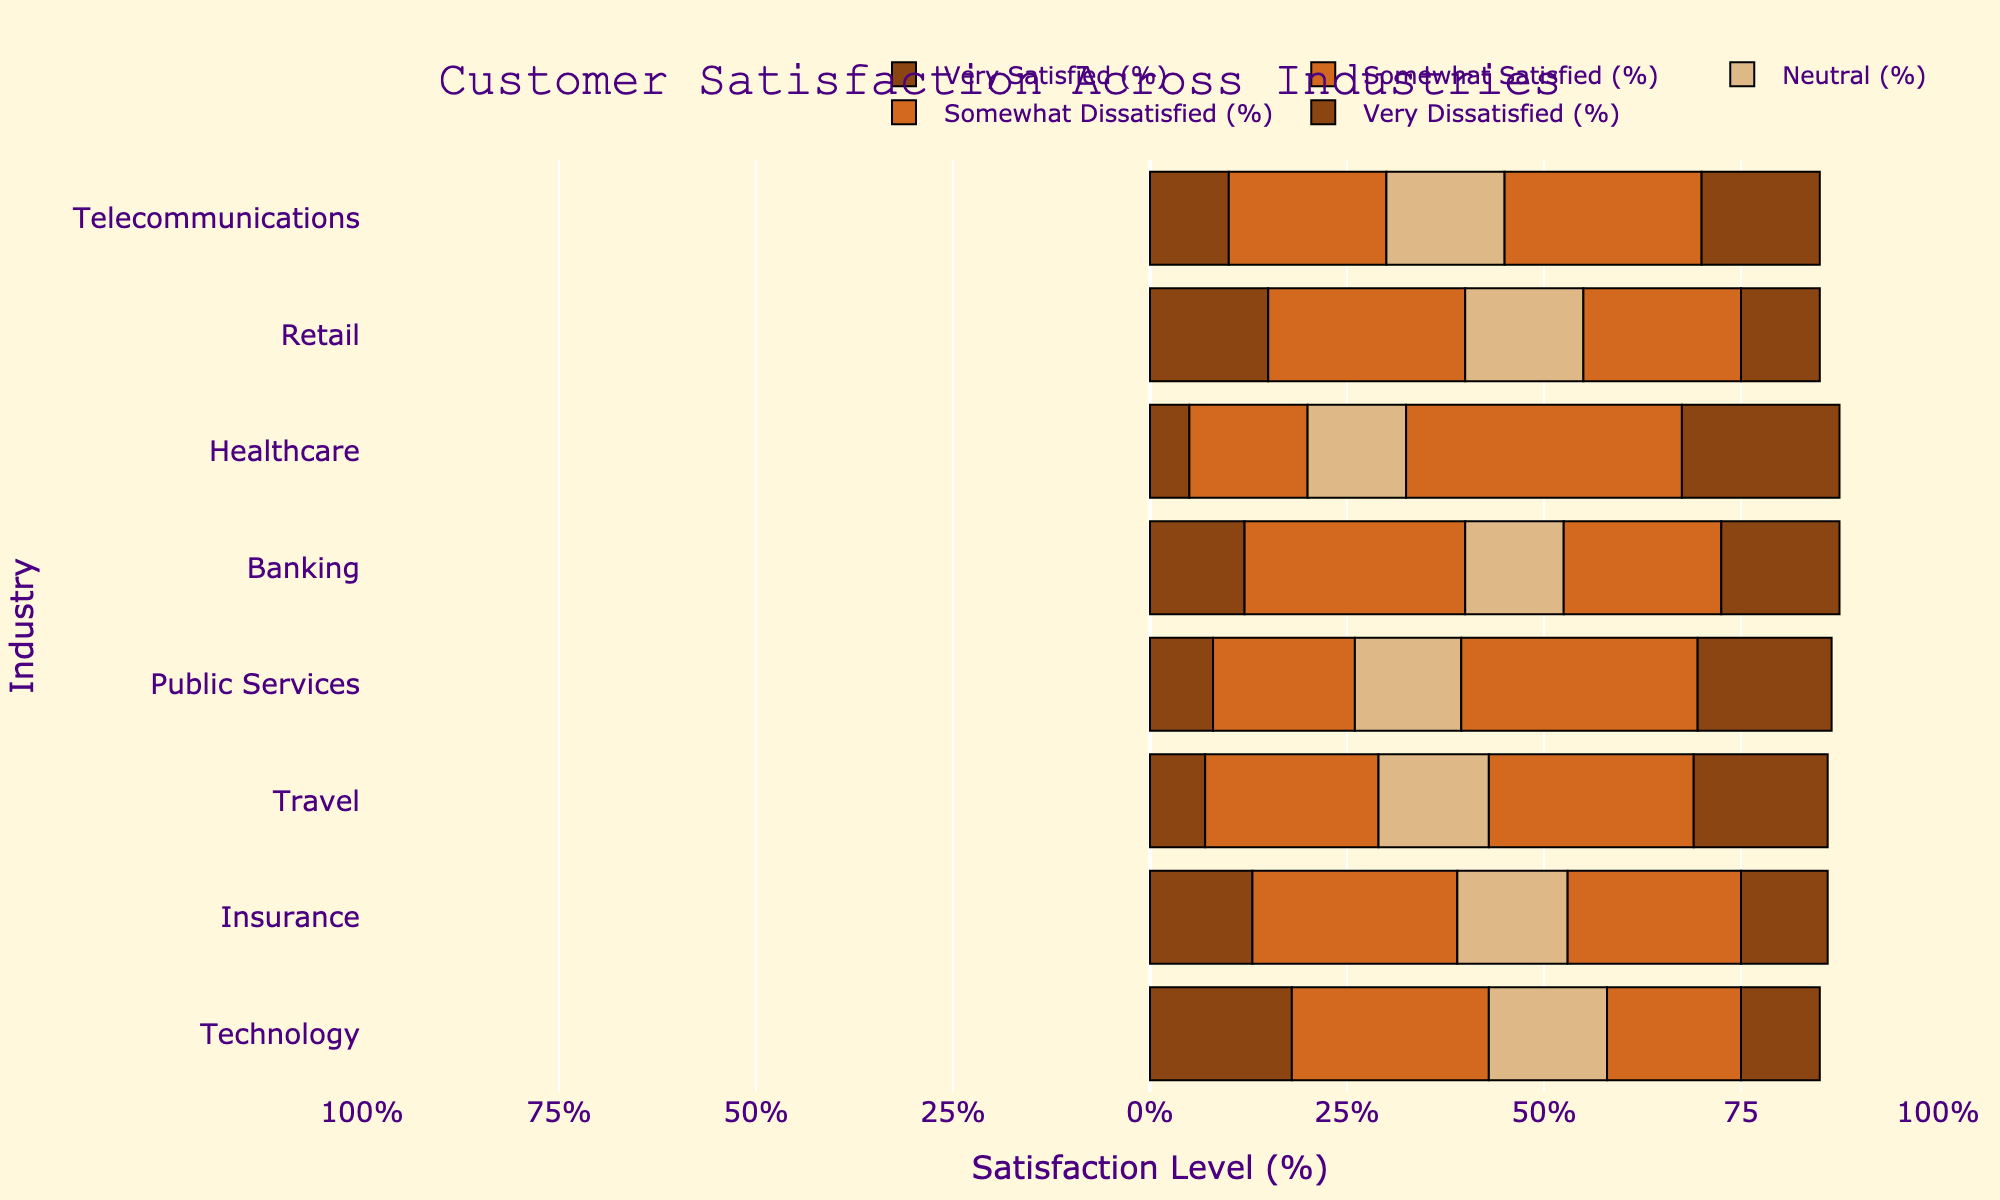Which industry has the highest percentage of 'Very Satisfied' customers? Look at the length of the bars representing 'Very Satisfied' customers for each industry and identify the industry with the longest bar.
Answer: Technology Which industry has the lowest percentage of 'Somewhat Dissatisfied' customers? Examine the lengths of the bars representing 'Somewhat Dissatisfied' for each industry and find the industry with the shortest bar.
Answer: Telecommunications How do the 'Very Satisfied' and 'Very Dissatisfied' rates in Telecommunications compare? Compare the lengths of the 'Very Satisfied' and 'Very Dissatisfied' bars for the Telecommunications industry.
Answer: 'Very Dissatisfied' is higher What is the combined percentage of 'Somewhat Satisfied' and 'Somewhat Dissatisfied' for Banking? Add the percentages of 'Somewhat Satisfied' (28%) and 'Somewhat Dissatisfied' (20%) for Banking.
Answer: 48% Which industry has the largest neutral (Neutral %) sentiment? Compare the lengths of the 'Neutral' bars across all industries and identify the longest one.
Answer: Technology, Retail, Insurance, Travel (all equal) In which industry do positive sentiments ('Very Satisfied' + 'Somewhat Satisfied') exceed negative sentiments ('Somewhat Dissatisfied' + 'Very Dissatisfied') the most? Calculate the sum of 'Very Satisfied' and 'Somewhat Satisfied' and the sum of 'Somewhat Dissatisfied' and 'Very Dissatisfied' for each industry and compare the differences. Identify where the positive exceeds negative sentiment the most.
Answer: Technology How does the 'Very Dissatisfied' rate in Healthcare compare to that in Travel? Compare the lengths of the 'Very Dissatisfied' bars for Healthcare and Travel.
Answer: Higher in Healthcare What is the average 'Very Dissatisfied' rate across all industries? Sum the 'Very Dissatisfied' percentages for all industries and divide by the number of industries (8). Calculation: (15+10+20+15+17+17+11+10)/8 = 14.375%
Answer: 14.375% Does any industry have equal percentages of 'Neutral' and 'Somewhat Dissatisfied' customers? Compare the lengths of 'Neutral' and 'Somewhat Dissatisfied' bars for each industry to see if any are equal.
Answer: No Which industry shows the smallest difference between 'Very Satisfied' and 'Somewhat Satisfied' rates? Calculate the difference between 'Very Satisfied' and 'Somewhat Satisfied' for each industry and identify the smallest difference.
Answer: Insurance 